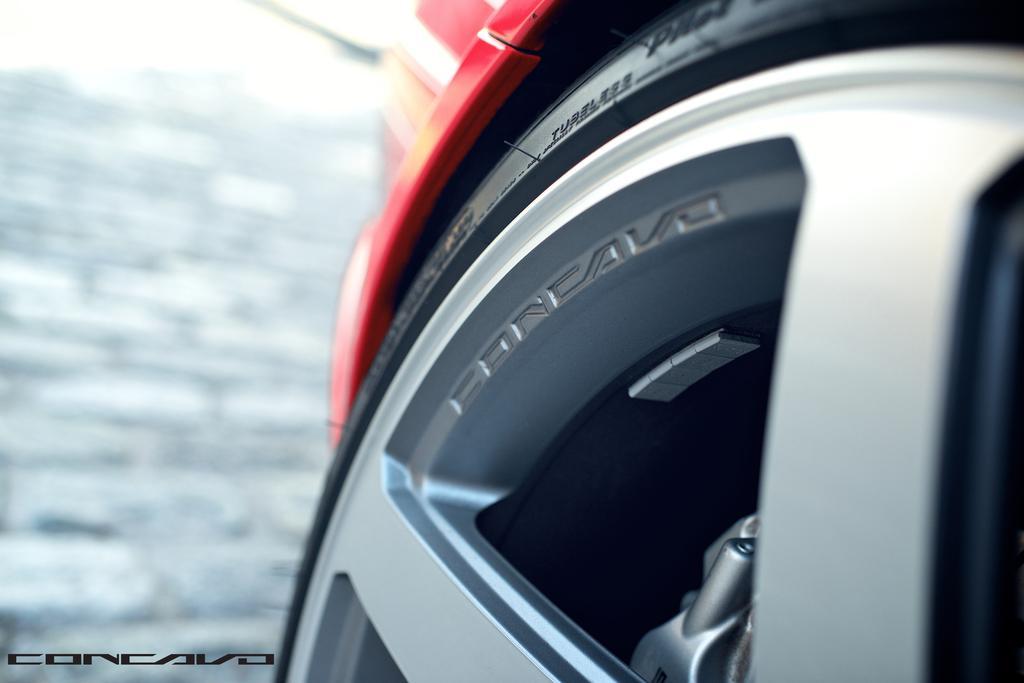Can you describe this image briefly? In this image, this looks like a vehicle wheel. This is a tyre, which is attached to the spokes. The background looks blurry. This is the watermark on the image. 